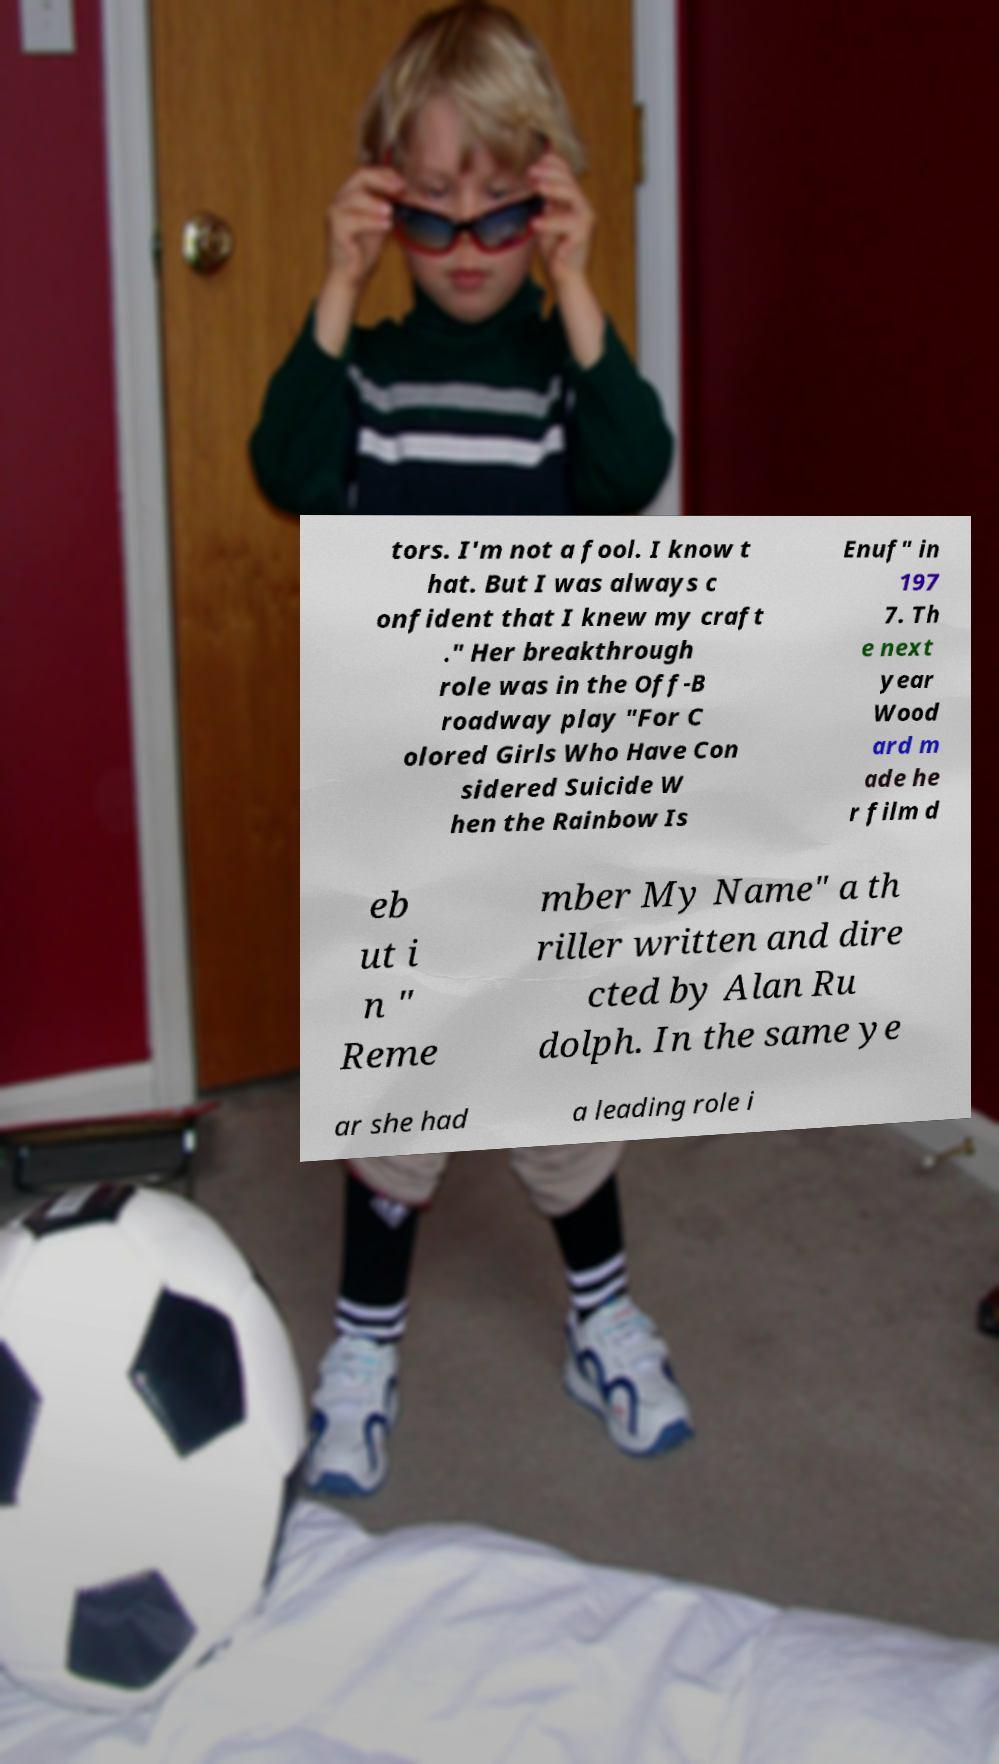Please identify and transcribe the text found in this image. tors. I'm not a fool. I know t hat. But I was always c onfident that I knew my craft ." Her breakthrough role was in the Off-B roadway play "For C olored Girls Who Have Con sidered Suicide W hen the Rainbow Is Enuf" in 197 7. Th e next year Wood ard m ade he r film d eb ut i n " Reme mber My Name" a th riller written and dire cted by Alan Ru dolph. In the same ye ar she had a leading role i 